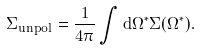Convert formula to latex. <formula><loc_0><loc_0><loc_500><loc_500>\Sigma _ { u n p o l } = \frac { 1 } { 4 \pi } \int d \Omega ^ { * } \Sigma ( \Omega ^ { * } ) .</formula> 